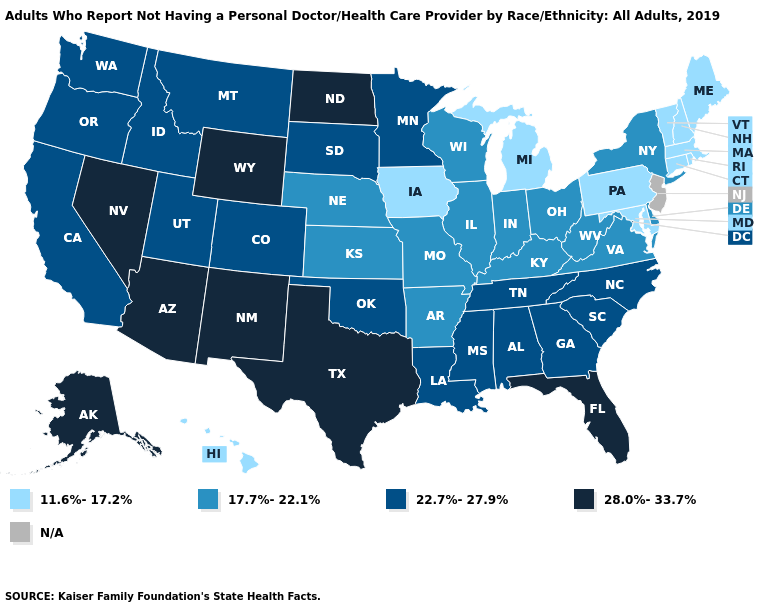Does Minnesota have the highest value in the MidWest?
Write a very short answer. No. Is the legend a continuous bar?
Be succinct. No. What is the lowest value in the USA?
Short answer required. 11.6%-17.2%. What is the value of South Dakota?
Quick response, please. 22.7%-27.9%. Which states hav the highest value in the MidWest?
Quick response, please. North Dakota. Which states have the lowest value in the USA?
Concise answer only. Connecticut, Hawaii, Iowa, Maine, Maryland, Massachusetts, Michigan, New Hampshire, Pennsylvania, Rhode Island, Vermont. What is the lowest value in the MidWest?
Keep it brief. 11.6%-17.2%. What is the value of New Hampshire?
Concise answer only. 11.6%-17.2%. Which states have the lowest value in the USA?
Short answer required. Connecticut, Hawaii, Iowa, Maine, Maryland, Massachusetts, Michigan, New Hampshire, Pennsylvania, Rhode Island, Vermont. Among the states that border Maryland , which have the highest value?
Keep it brief. Delaware, Virginia, West Virginia. What is the value of Georgia?
Give a very brief answer. 22.7%-27.9%. Name the states that have a value in the range 22.7%-27.9%?
Keep it brief. Alabama, California, Colorado, Georgia, Idaho, Louisiana, Minnesota, Mississippi, Montana, North Carolina, Oklahoma, Oregon, South Carolina, South Dakota, Tennessee, Utah, Washington. 